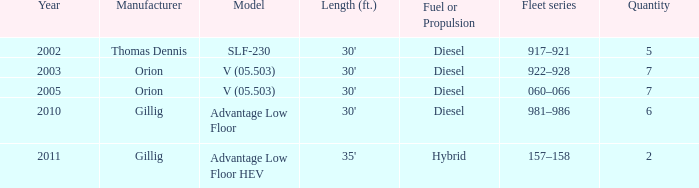Can you provide the fleet series that has five in quantity? 917–921. 